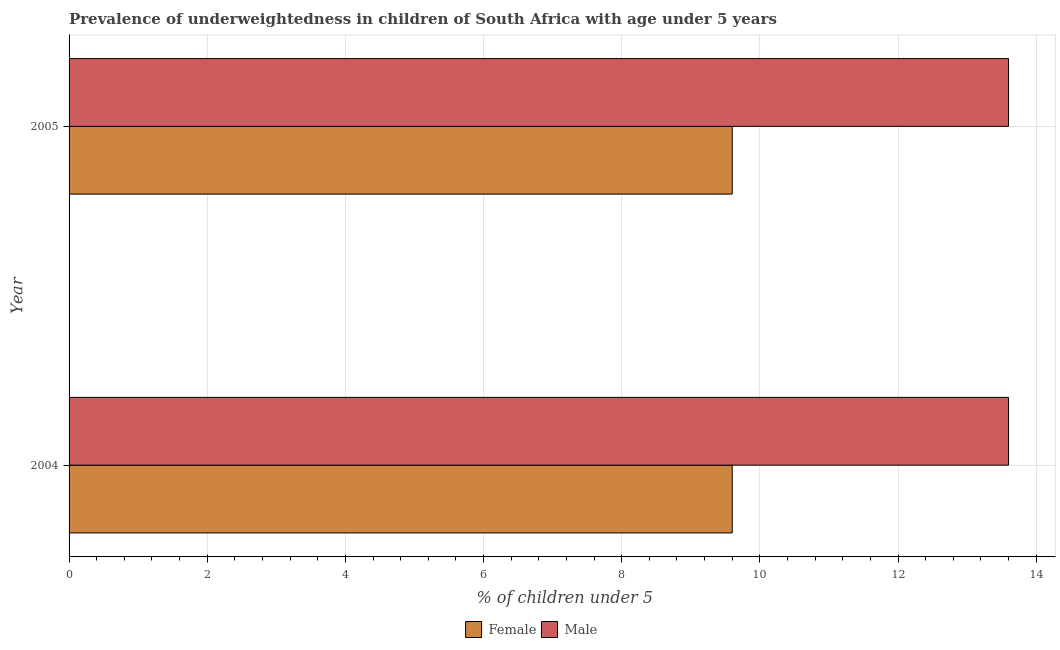Are the number of bars per tick equal to the number of legend labels?
Give a very brief answer. Yes. How many bars are there on the 1st tick from the bottom?
Your response must be concise. 2. What is the percentage of underweighted male children in 2004?
Ensure brevity in your answer.  13.6. Across all years, what is the maximum percentage of underweighted male children?
Offer a terse response. 13.6. Across all years, what is the minimum percentage of underweighted female children?
Give a very brief answer. 9.6. In which year was the percentage of underweighted female children minimum?
Offer a terse response. 2004. What is the total percentage of underweighted female children in the graph?
Your answer should be compact. 19.2. What is the difference between the percentage of underweighted male children in 2004 and that in 2005?
Make the answer very short. 0. What is the difference between the percentage of underweighted male children in 2005 and the percentage of underweighted female children in 2004?
Your answer should be very brief. 4. What is the average percentage of underweighted male children per year?
Give a very brief answer. 13.6. In the year 2004, what is the difference between the percentage of underweighted male children and percentage of underweighted female children?
Offer a very short reply. 4. What does the 1st bar from the bottom in 2005 represents?
Provide a succinct answer. Female. Are all the bars in the graph horizontal?
Your answer should be very brief. Yes. What is the difference between two consecutive major ticks on the X-axis?
Ensure brevity in your answer.  2. Are the values on the major ticks of X-axis written in scientific E-notation?
Provide a succinct answer. No. Does the graph contain any zero values?
Your answer should be compact. No. Does the graph contain grids?
Offer a very short reply. Yes. How many legend labels are there?
Offer a very short reply. 2. What is the title of the graph?
Give a very brief answer. Prevalence of underweightedness in children of South Africa with age under 5 years. Does "Not attending school" appear as one of the legend labels in the graph?
Offer a very short reply. No. What is the label or title of the X-axis?
Your answer should be very brief.  % of children under 5. What is the  % of children under 5 of Female in 2004?
Ensure brevity in your answer.  9.6. What is the  % of children under 5 of Male in 2004?
Provide a short and direct response. 13.6. What is the  % of children under 5 of Female in 2005?
Your answer should be very brief. 9.6. What is the  % of children under 5 of Male in 2005?
Your answer should be compact. 13.6. Across all years, what is the maximum  % of children under 5 in Female?
Make the answer very short. 9.6. Across all years, what is the maximum  % of children under 5 in Male?
Your answer should be compact. 13.6. Across all years, what is the minimum  % of children under 5 of Female?
Your response must be concise. 9.6. Across all years, what is the minimum  % of children under 5 in Male?
Offer a very short reply. 13.6. What is the total  % of children under 5 in Female in the graph?
Keep it short and to the point. 19.2. What is the total  % of children under 5 of Male in the graph?
Provide a succinct answer. 27.2. What is the difference between the  % of children under 5 of Male in 2004 and that in 2005?
Make the answer very short. 0. What is the average  % of children under 5 of Female per year?
Your answer should be very brief. 9.6. What is the average  % of children under 5 in Male per year?
Keep it short and to the point. 13.6. In the year 2004, what is the difference between the  % of children under 5 in Female and  % of children under 5 in Male?
Offer a terse response. -4. In the year 2005, what is the difference between the  % of children under 5 in Female and  % of children under 5 in Male?
Your answer should be very brief. -4. What is the ratio of the  % of children under 5 in Female in 2004 to that in 2005?
Keep it short and to the point. 1. What is the ratio of the  % of children under 5 of Male in 2004 to that in 2005?
Provide a short and direct response. 1. What is the difference between the highest and the lowest  % of children under 5 of Female?
Make the answer very short. 0. What is the difference between the highest and the lowest  % of children under 5 in Male?
Keep it short and to the point. 0. 